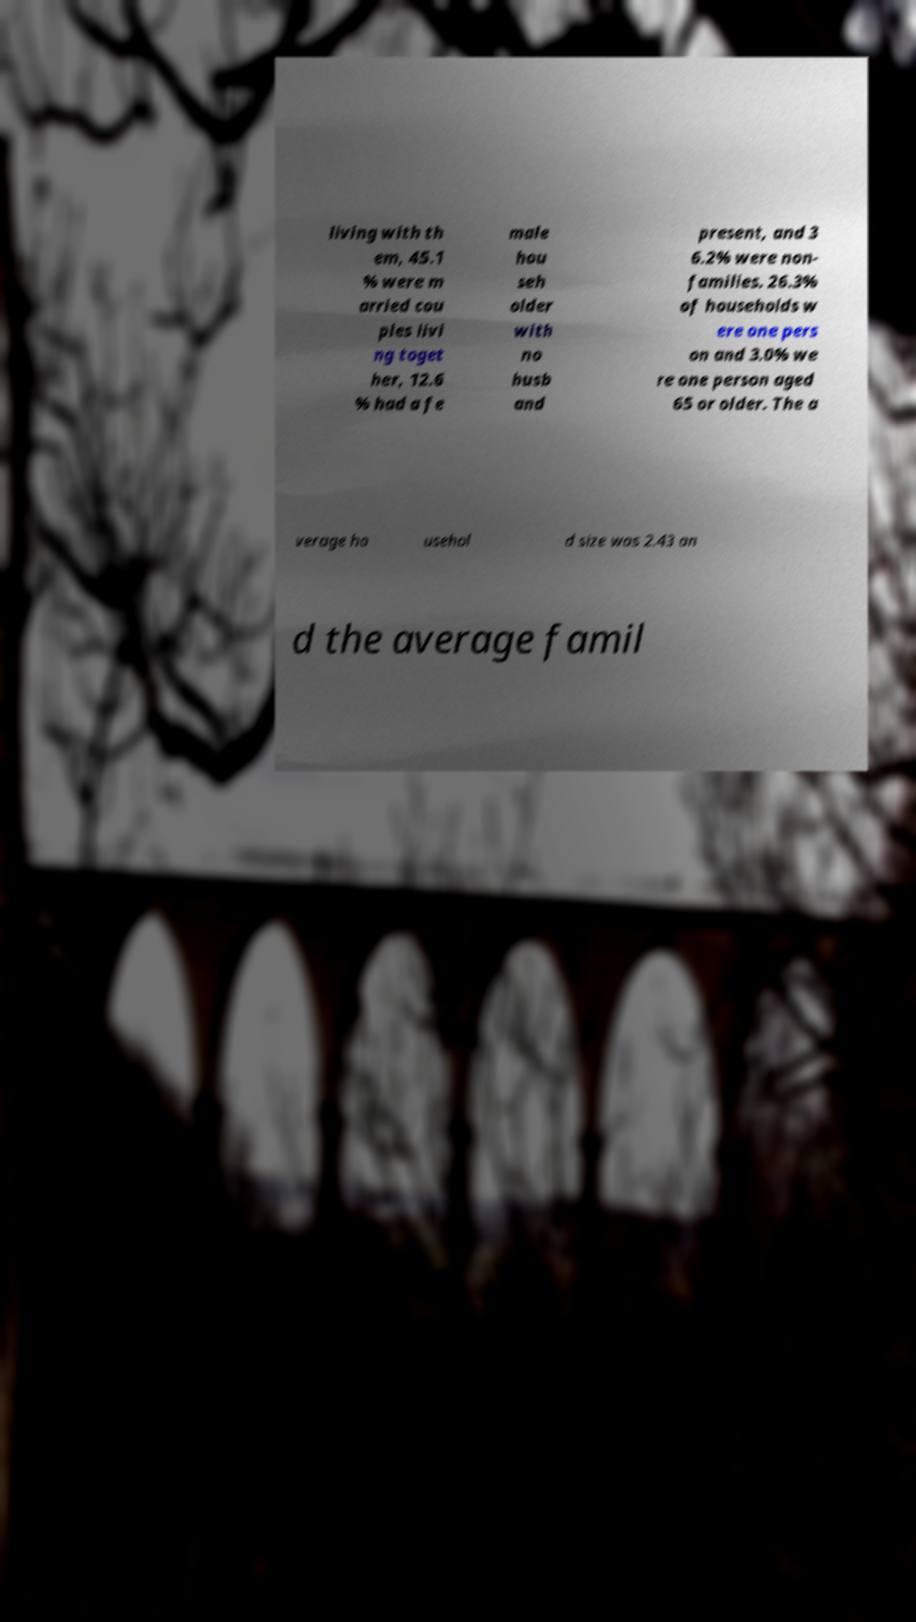I need the written content from this picture converted into text. Can you do that? living with th em, 45.1 % were m arried cou ples livi ng toget her, 12.6 % had a fe male hou seh older with no husb and present, and 3 6.2% were non- families. 26.3% of households w ere one pers on and 3.0% we re one person aged 65 or older. The a verage ho usehol d size was 2.43 an d the average famil 